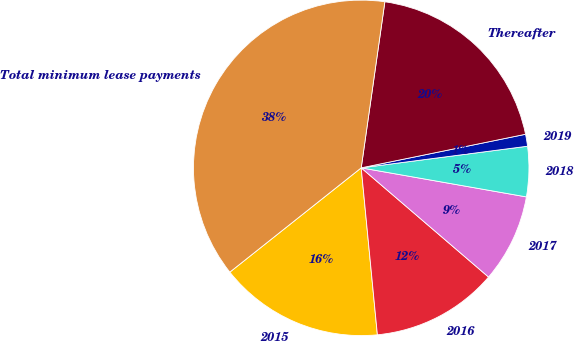<chart> <loc_0><loc_0><loc_500><loc_500><pie_chart><fcel>2015<fcel>2016<fcel>2017<fcel>2018<fcel>2019<fcel>Thereafter<fcel>Total minimum lease payments<nl><fcel>15.86%<fcel>12.18%<fcel>8.51%<fcel>4.83%<fcel>1.15%<fcel>19.54%<fcel>37.93%<nl></chart> 